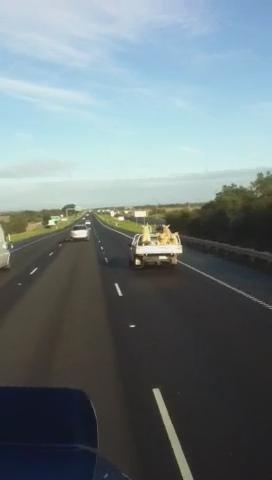How many lanes are on the road?
Give a very brief answer. 3. 